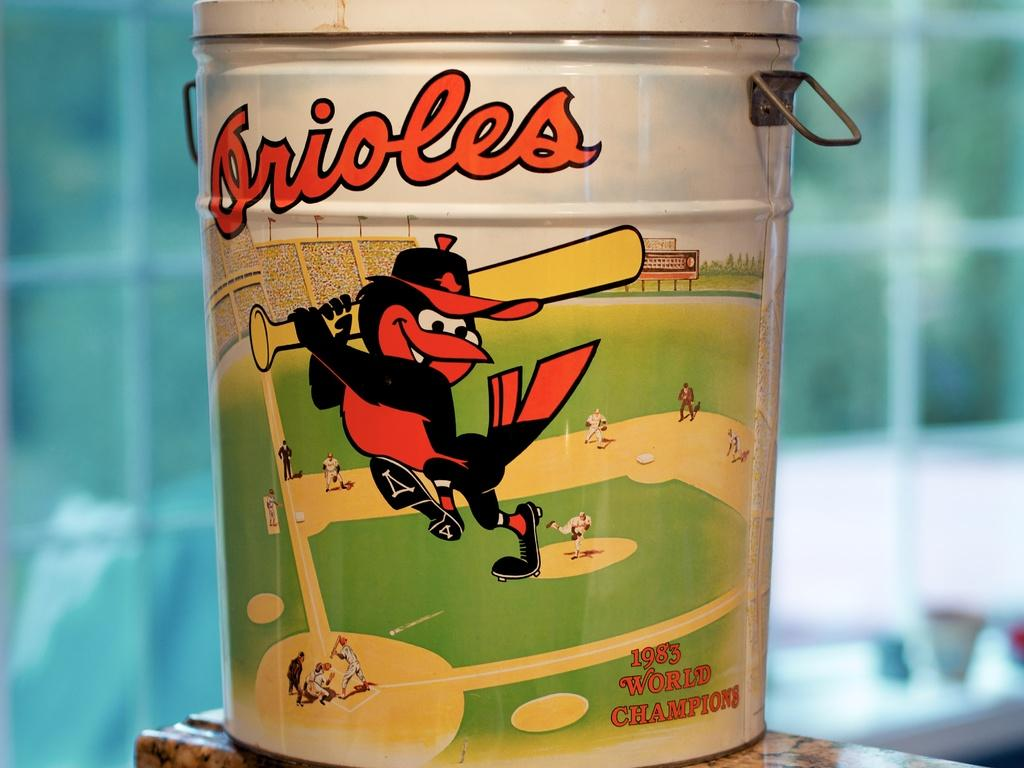<image>
Provide a brief description of the given image. An aluminum bucket from the 1983 World Champions, featuring the Orioles, sits on a ceramic countertop. 